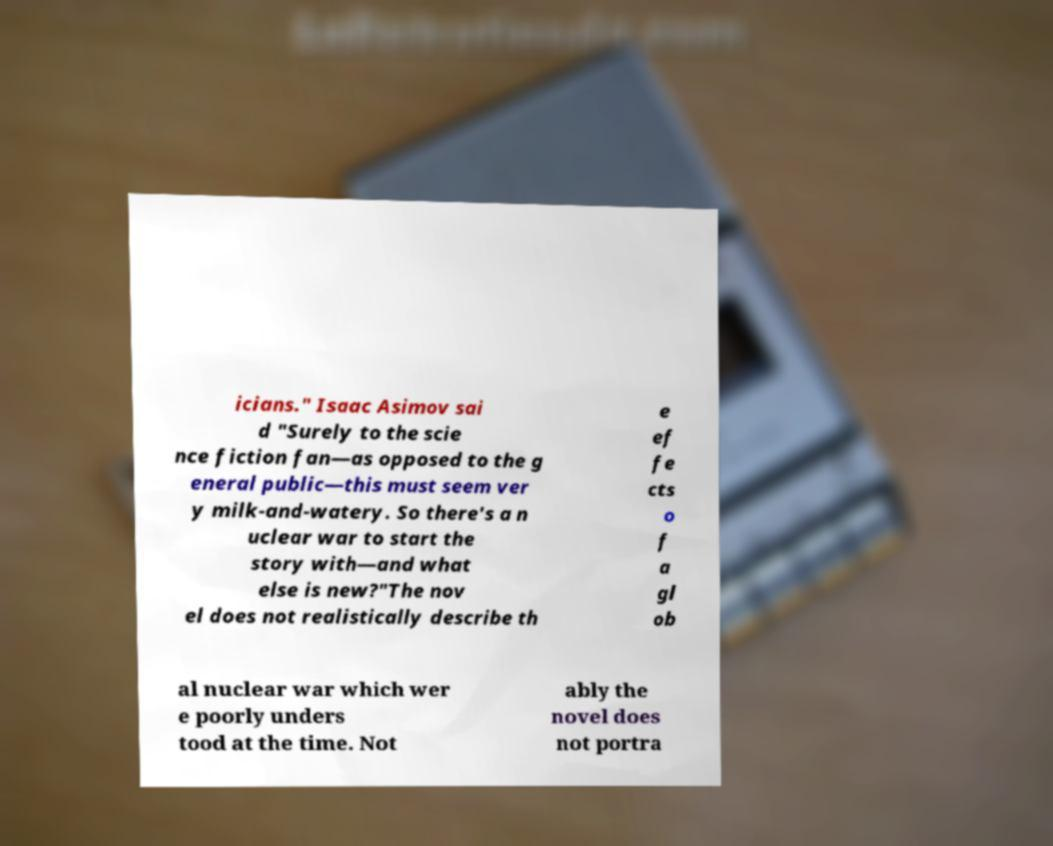Can you read and provide the text displayed in the image?This photo seems to have some interesting text. Can you extract and type it out for me? icians." Isaac Asimov sai d "Surely to the scie nce fiction fan—as opposed to the g eneral public—this must seem ver y milk-and-watery. So there's a n uclear war to start the story with—and what else is new?"The nov el does not realistically describe th e ef fe cts o f a gl ob al nuclear war which wer e poorly unders tood at the time. Not ably the novel does not portra 